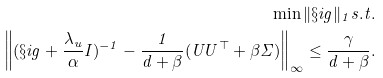Convert formula to latex. <formula><loc_0><loc_0><loc_500><loc_500>\min \| \S i g \| _ { 1 } s . t . \\ \left \| ( \S i g + \frac { \lambda _ { u } } { \alpha } I ) ^ { - 1 } - \frac { 1 } { d + \beta } ( U U ^ { \top } + \beta \Sigma ) \right \| _ { \infty } \leq \frac { \gamma } { d + \beta } .</formula> 